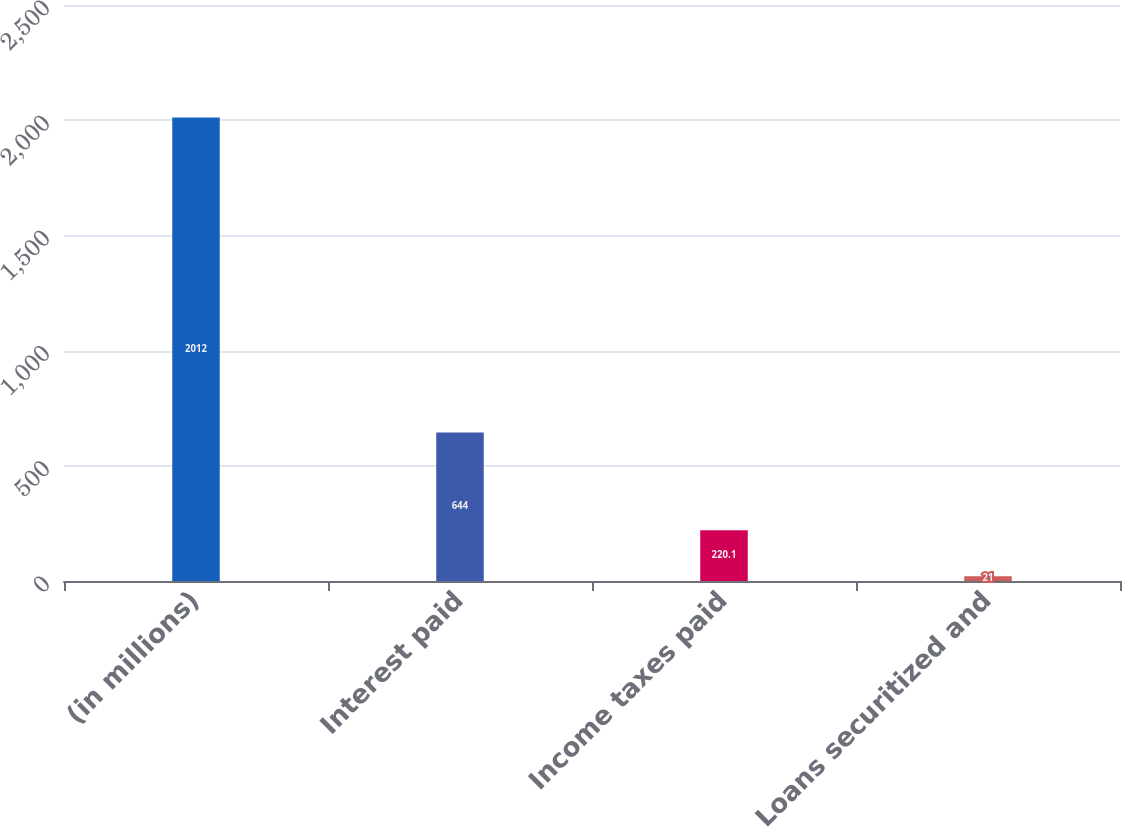<chart> <loc_0><loc_0><loc_500><loc_500><bar_chart><fcel>(in millions)<fcel>Interest paid<fcel>Income taxes paid<fcel>Loans securitized and<nl><fcel>2012<fcel>644<fcel>220.1<fcel>21<nl></chart> 